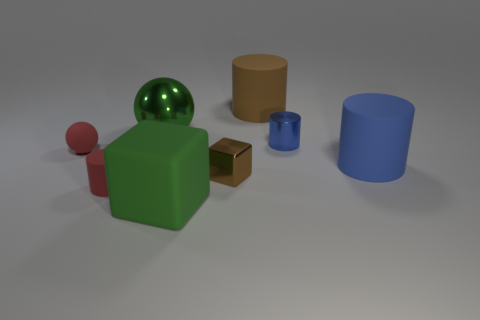Subtract all tiny blue metal cylinders. How many cylinders are left? 3 Subtract all brown balls. How many blue cylinders are left? 2 Add 1 small matte things. How many objects exist? 9 Subtract all brown cylinders. How many cylinders are left? 3 Subtract 2 cylinders. How many cylinders are left? 2 Subtract all spheres. How many objects are left? 6 Add 7 large gray rubber objects. How many large gray rubber objects exist? 7 Subtract 1 blue cylinders. How many objects are left? 7 Subtract all red balls. Subtract all cyan cubes. How many balls are left? 1 Subtract all blue objects. Subtract all small blocks. How many objects are left? 5 